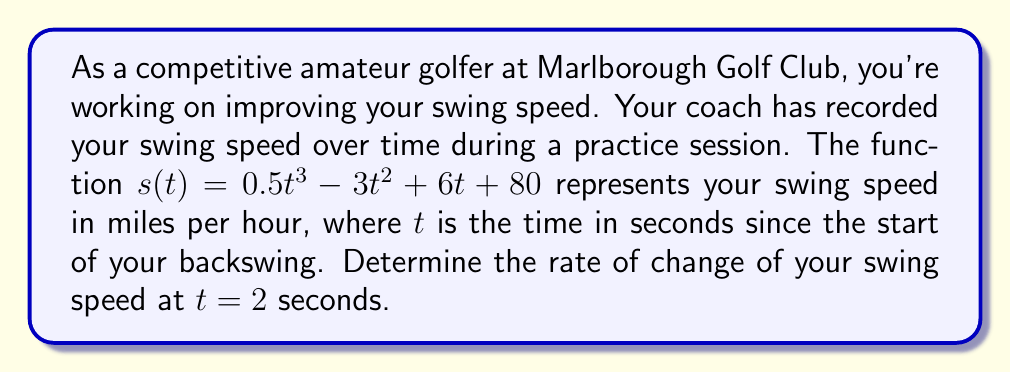Give your solution to this math problem. To find the rate of change of swing speed at a specific time, we need to calculate the derivative of the given function and evaluate it at the specified time.

1) First, let's find the derivative of $s(t)$:
   
   $s(t) = 0.5t^3 - 3t^2 + 6t + 80$
   
   Using the power rule and constant rule of differentiation:
   
   $s'(t) = 1.5t^2 - 6t + 6$

2) Now that we have the derivative, which represents the instantaneous rate of change of swing speed, we need to evaluate it at $t = 2$ seconds:

   $s'(2) = 1.5(2)^2 - 6(2) + 6$
   
   $= 1.5(4) - 12 + 6$
   
   $= 6 - 12 + 6$
   
   $= 0$

3) The result indicates that at exactly 2 seconds into your swing, the rate of change of your swing speed is 0 mph/s. This suggests that at this precise moment, your swing speed is neither increasing nor decreasing - it has reached a momentary plateau or turning point.

4) In the context of a golf swing, this could represent the transition point between your backswing and downswing, where your club momentarily comes to a stop before changing direction.
Answer: The rate of change of swing speed at $t = 2$ seconds is 0 mph/s. 